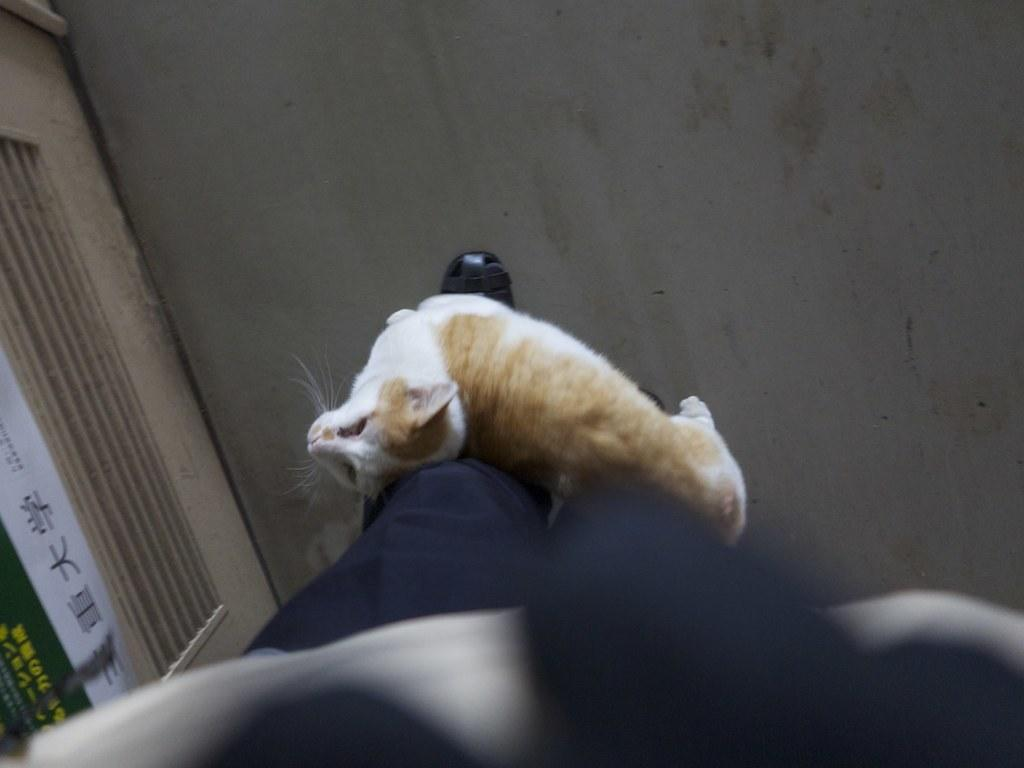What body part is visible in the image? There are a person's legs in the image. What animal can be seen on the floor in the image? There is a cat on the floor in the image. What object with writing on it is present in the image? There is an object with writing on it in the image. What type of orange is being peeled by the person in the image? There is no orange present in the image; only a person's legs are visible. 